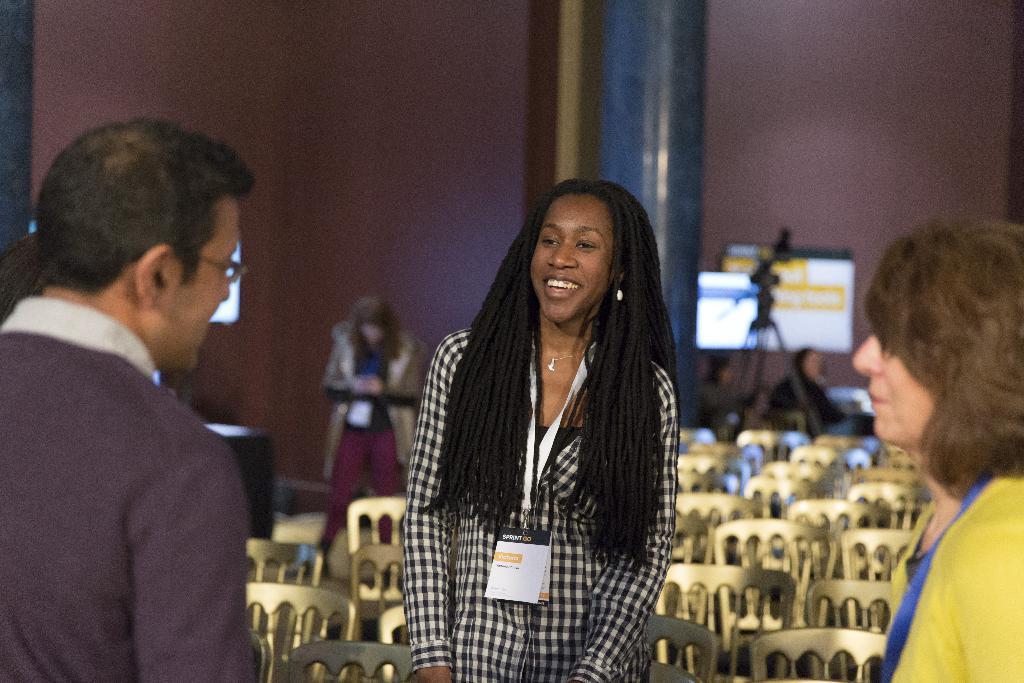Please provide a concise description of this image. Front these three people are standing. This woman wore an id card and smiling. Background there are chairs, camera with stand, screen, people and pillar.  